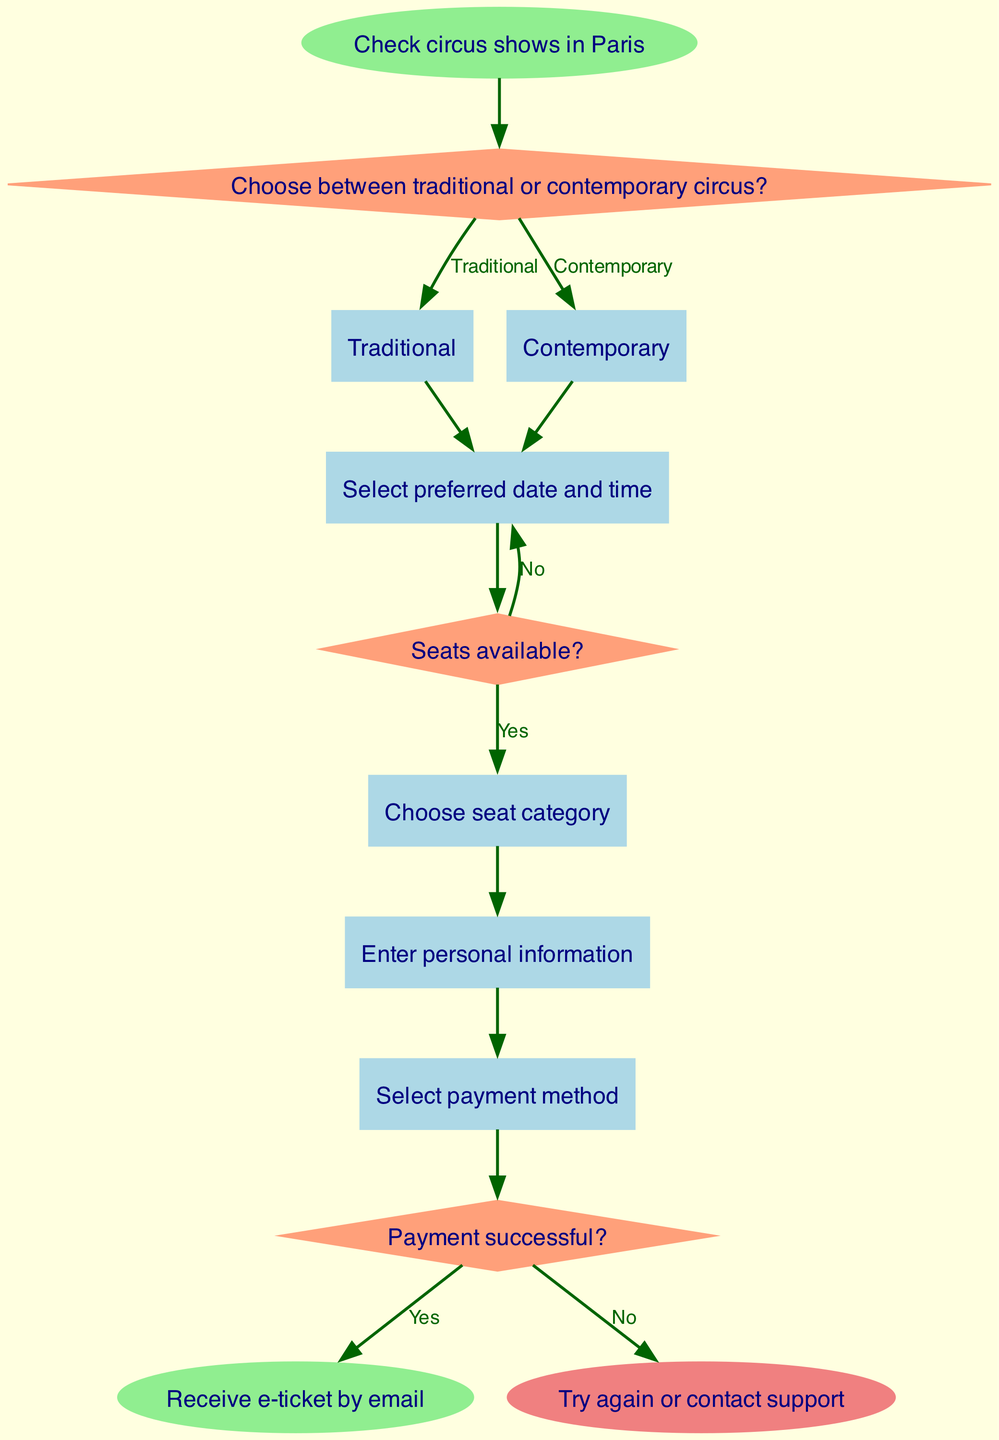What is the starting point of the flow chart? The starting point of the flow chart is labeled "Check circus shows in Paris." It is the first action before any decisions are made.
Answer: Check circus shows in Paris How many decision nodes are in the diagram? The diagram contains three decision nodes: one that asks whether to choose between traditional or contemporary circus, one that checks if seats are available, and one that confirms if the payment was successful.
Answer: 3 What is the output if the payment is successful? If the payment is successful, the next step in the flow is to receive the e-ticket by email, as indicated by the flow leading from the payment decision node to the end node for successful output.
Answer: Receive e-ticket by email What are the options after selecting the type of circus? After selecting the type of circus, the next action is to select a preferred date and time, followed by checking the availability of seats, which are the sequential processes following the initial decision.
Answer: Select preferred date and time What happens if there are no seats available? If there are no seats available, the flow leads back to the step of selecting a preferred date and time, indicating a retry at that decision point. The participant has the option to try again or contact support if the payment fails.
Answer: Try again or contact support Which process follows the selection of the seat category? The process that follows the selection of the seat category is entering personal information. After choosing a seat, the next step is to collect user details needed for the ticket purchase.
Answer: Enter personal information What type of circus can be chosen in the first decision? The two types of circus that can be chosen in the first decision are traditional and contemporary. This sets the stage for the subsequent actions that follow.
Answer: Traditional or Contemporary What is the second decision in the diagram? The second decision in the diagram asks, "Seats available?" This question determines the next steps based on seat availability for the selected circus show.
Answer: Seats available? 